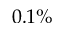<formula> <loc_0><loc_0><loc_500><loc_500>0 . 1 \%</formula> 